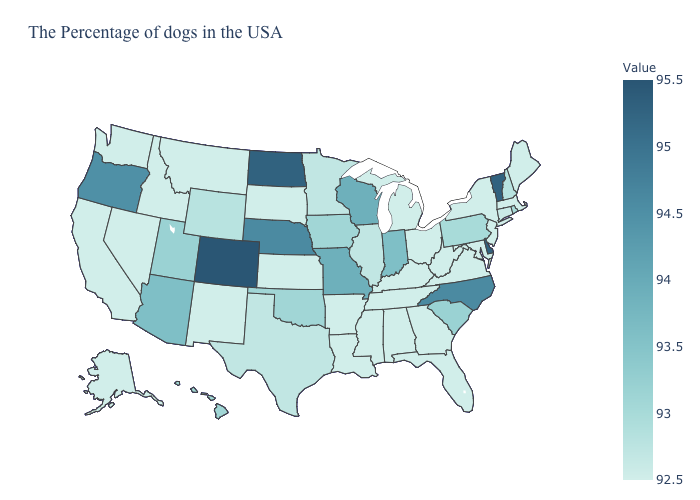Which states have the lowest value in the USA?
Answer briefly. Maine, Massachusetts, New York, New Jersey, Maryland, Virginia, West Virginia, Ohio, Florida, Georgia, Michigan, Kentucky, Alabama, Tennessee, Mississippi, Louisiana, Arkansas, Kansas, South Dakota, New Mexico, Montana, Idaho, Nevada, California, Washington, Alaska. Among the states that border Iowa , does South Dakota have the lowest value?
Concise answer only. Yes. Does Tennessee have the lowest value in the South?
Be succinct. Yes. Which states have the lowest value in the West?
Concise answer only. New Mexico, Montana, Idaho, Nevada, California, Washington, Alaska. 